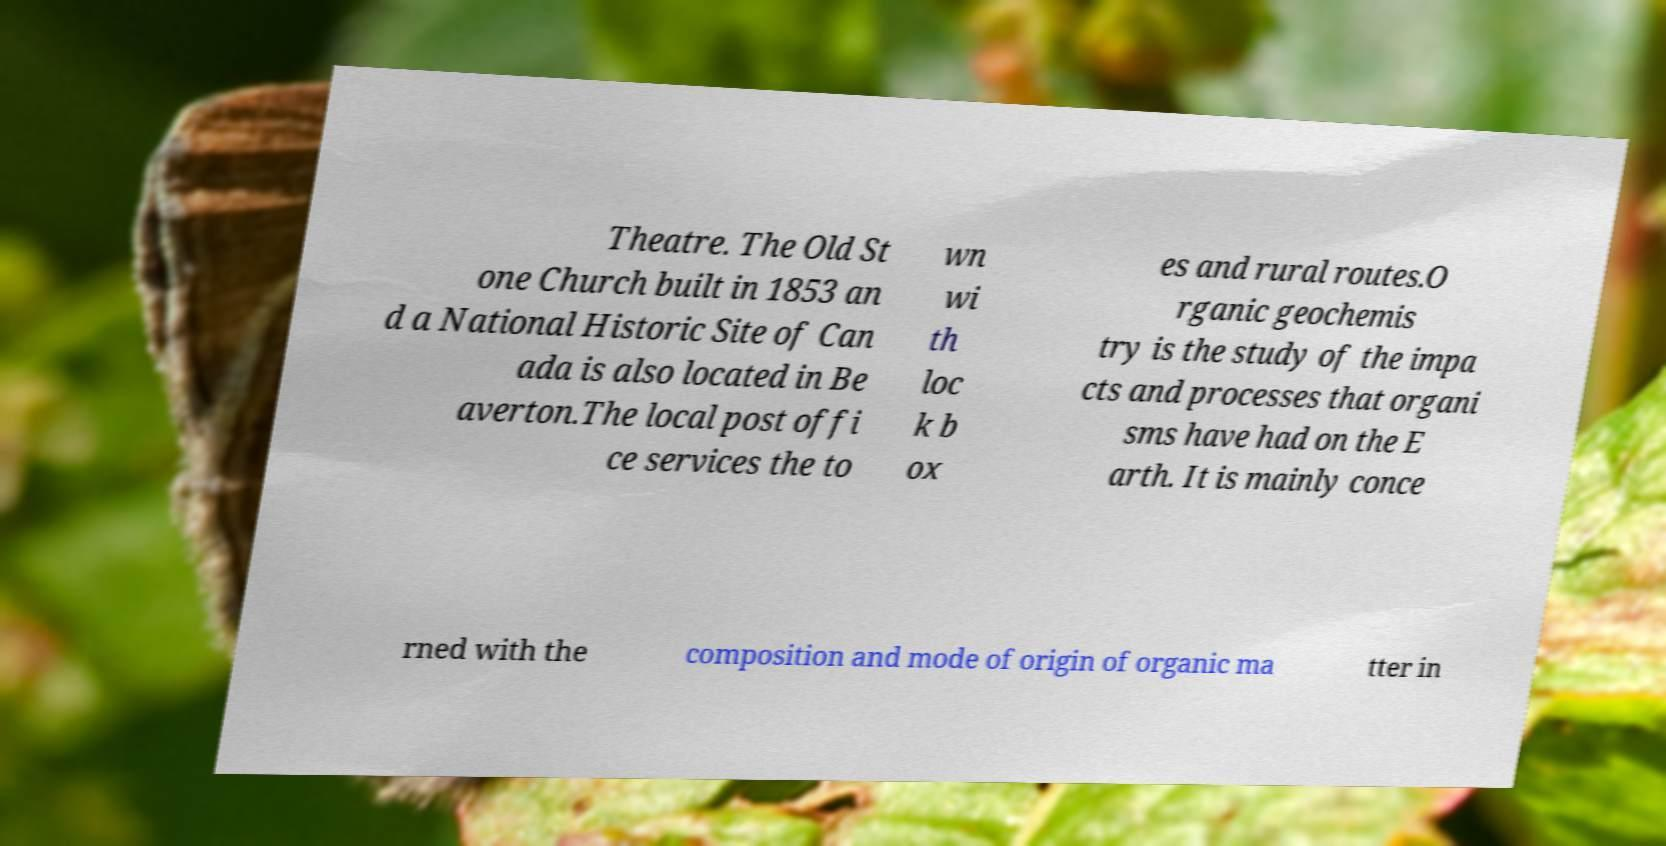For documentation purposes, I need the text within this image transcribed. Could you provide that? Theatre. The Old St one Church built in 1853 an d a National Historic Site of Can ada is also located in Be averton.The local post offi ce services the to wn wi th loc k b ox es and rural routes.O rganic geochemis try is the study of the impa cts and processes that organi sms have had on the E arth. It is mainly conce rned with the composition and mode of origin of organic ma tter in 